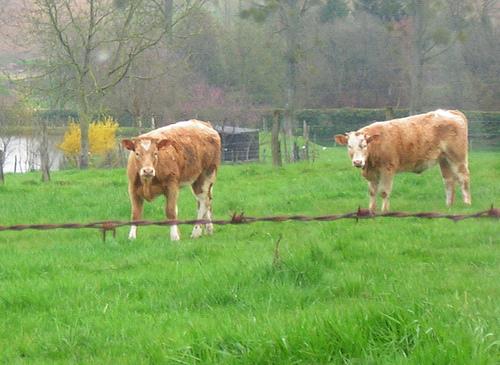Are these cows enclosed in the field?
Give a very brief answer. Yes. How many cows are there?
Quick response, please. 2. Are the cows sleeping?
Write a very short answer. No. 